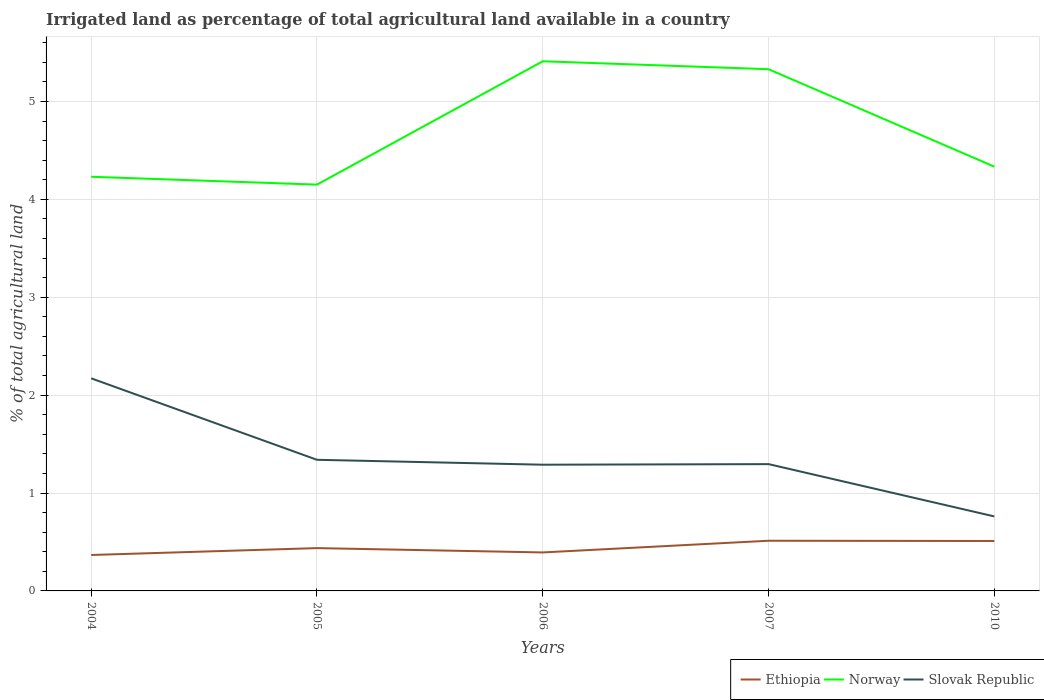Does the line corresponding to Ethiopia intersect with the line corresponding to Norway?
Give a very brief answer. No. Across all years, what is the maximum percentage of irrigated land in Slovak Republic?
Offer a very short reply. 0.76. In which year was the percentage of irrigated land in Norway maximum?
Provide a short and direct response. 2005. What is the total percentage of irrigated land in Norway in the graph?
Ensure brevity in your answer.  -0.1. What is the difference between the highest and the second highest percentage of irrigated land in Slovak Republic?
Keep it short and to the point. 1.41. Is the percentage of irrigated land in Slovak Republic strictly greater than the percentage of irrigated land in Ethiopia over the years?
Give a very brief answer. No. Does the graph contain grids?
Keep it short and to the point. Yes. How are the legend labels stacked?
Your answer should be compact. Horizontal. What is the title of the graph?
Your answer should be compact. Irrigated land as percentage of total agricultural land available in a country. What is the label or title of the X-axis?
Provide a succinct answer. Years. What is the label or title of the Y-axis?
Ensure brevity in your answer.  % of total agricultural land. What is the % of total agricultural land in Ethiopia in 2004?
Give a very brief answer. 0.37. What is the % of total agricultural land of Norway in 2004?
Make the answer very short. 4.23. What is the % of total agricultural land in Slovak Republic in 2004?
Provide a succinct answer. 2.17. What is the % of total agricultural land of Ethiopia in 2005?
Provide a succinct answer. 0.44. What is the % of total agricultural land in Norway in 2005?
Your answer should be very brief. 4.15. What is the % of total agricultural land in Slovak Republic in 2005?
Your answer should be very brief. 1.34. What is the % of total agricultural land in Ethiopia in 2006?
Your response must be concise. 0.39. What is the % of total agricultural land in Norway in 2006?
Your response must be concise. 5.41. What is the % of total agricultural land of Slovak Republic in 2006?
Your answer should be compact. 1.29. What is the % of total agricultural land in Ethiopia in 2007?
Your answer should be compact. 0.51. What is the % of total agricultural land of Norway in 2007?
Your response must be concise. 5.33. What is the % of total agricultural land of Slovak Republic in 2007?
Your response must be concise. 1.3. What is the % of total agricultural land of Ethiopia in 2010?
Provide a succinct answer. 0.51. What is the % of total agricultural land of Norway in 2010?
Give a very brief answer. 4.33. What is the % of total agricultural land in Slovak Republic in 2010?
Your answer should be compact. 0.76. Across all years, what is the maximum % of total agricultural land of Ethiopia?
Your response must be concise. 0.51. Across all years, what is the maximum % of total agricultural land of Norway?
Make the answer very short. 5.41. Across all years, what is the maximum % of total agricultural land of Slovak Republic?
Provide a short and direct response. 2.17. Across all years, what is the minimum % of total agricultural land of Ethiopia?
Your answer should be very brief. 0.37. Across all years, what is the minimum % of total agricultural land in Norway?
Provide a short and direct response. 4.15. Across all years, what is the minimum % of total agricultural land in Slovak Republic?
Your response must be concise. 0.76. What is the total % of total agricultural land of Ethiopia in the graph?
Offer a terse response. 2.22. What is the total % of total agricultural land in Norway in the graph?
Provide a short and direct response. 23.46. What is the total % of total agricultural land in Slovak Republic in the graph?
Provide a short and direct response. 6.86. What is the difference between the % of total agricultural land in Ethiopia in 2004 and that in 2005?
Provide a succinct answer. -0.07. What is the difference between the % of total agricultural land in Norway in 2004 and that in 2005?
Provide a succinct answer. 0.08. What is the difference between the % of total agricultural land in Slovak Republic in 2004 and that in 2005?
Offer a very short reply. 0.83. What is the difference between the % of total agricultural land of Ethiopia in 2004 and that in 2006?
Your response must be concise. -0.03. What is the difference between the % of total agricultural land of Norway in 2004 and that in 2006?
Provide a short and direct response. -1.18. What is the difference between the % of total agricultural land in Slovak Republic in 2004 and that in 2006?
Give a very brief answer. 0.88. What is the difference between the % of total agricultural land of Ethiopia in 2004 and that in 2007?
Ensure brevity in your answer.  -0.15. What is the difference between the % of total agricultural land of Norway in 2004 and that in 2007?
Your response must be concise. -1.1. What is the difference between the % of total agricultural land in Slovak Republic in 2004 and that in 2007?
Your answer should be very brief. 0.88. What is the difference between the % of total agricultural land in Ethiopia in 2004 and that in 2010?
Offer a very short reply. -0.14. What is the difference between the % of total agricultural land in Norway in 2004 and that in 2010?
Make the answer very short. -0.1. What is the difference between the % of total agricultural land in Slovak Republic in 2004 and that in 2010?
Keep it short and to the point. 1.41. What is the difference between the % of total agricultural land of Ethiopia in 2005 and that in 2006?
Provide a short and direct response. 0.04. What is the difference between the % of total agricultural land in Norway in 2005 and that in 2006?
Offer a very short reply. -1.26. What is the difference between the % of total agricultural land of Slovak Republic in 2005 and that in 2006?
Your response must be concise. 0.05. What is the difference between the % of total agricultural land in Ethiopia in 2005 and that in 2007?
Your response must be concise. -0.08. What is the difference between the % of total agricultural land in Norway in 2005 and that in 2007?
Keep it short and to the point. -1.18. What is the difference between the % of total agricultural land of Slovak Republic in 2005 and that in 2007?
Your response must be concise. 0.04. What is the difference between the % of total agricultural land of Ethiopia in 2005 and that in 2010?
Offer a terse response. -0.07. What is the difference between the % of total agricultural land of Norway in 2005 and that in 2010?
Provide a succinct answer. -0.18. What is the difference between the % of total agricultural land in Slovak Republic in 2005 and that in 2010?
Your answer should be very brief. 0.58. What is the difference between the % of total agricultural land of Ethiopia in 2006 and that in 2007?
Provide a succinct answer. -0.12. What is the difference between the % of total agricultural land in Norway in 2006 and that in 2007?
Provide a short and direct response. 0.08. What is the difference between the % of total agricultural land in Slovak Republic in 2006 and that in 2007?
Make the answer very short. -0.01. What is the difference between the % of total agricultural land in Ethiopia in 2006 and that in 2010?
Your response must be concise. -0.12. What is the difference between the % of total agricultural land in Norway in 2006 and that in 2010?
Your answer should be compact. 1.08. What is the difference between the % of total agricultural land in Slovak Republic in 2006 and that in 2010?
Provide a succinct answer. 0.53. What is the difference between the % of total agricultural land in Ethiopia in 2007 and that in 2010?
Ensure brevity in your answer.  0. What is the difference between the % of total agricultural land of Norway in 2007 and that in 2010?
Your answer should be very brief. 1. What is the difference between the % of total agricultural land in Slovak Republic in 2007 and that in 2010?
Give a very brief answer. 0.53. What is the difference between the % of total agricultural land of Ethiopia in 2004 and the % of total agricultural land of Norway in 2005?
Your response must be concise. -3.78. What is the difference between the % of total agricultural land of Ethiopia in 2004 and the % of total agricultural land of Slovak Republic in 2005?
Provide a short and direct response. -0.97. What is the difference between the % of total agricultural land of Norway in 2004 and the % of total agricultural land of Slovak Republic in 2005?
Your answer should be very brief. 2.89. What is the difference between the % of total agricultural land in Ethiopia in 2004 and the % of total agricultural land in Norway in 2006?
Provide a short and direct response. -5.04. What is the difference between the % of total agricultural land of Ethiopia in 2004 and the % of total agricultural land of Slovak Republic in 2006?
Offer a terse response. -0.92. What is the difference between the % of total agricultural land of Norway in 2004 and the % of total agricultural land of Slovak Republic in 2006?
Keep it short and to the point. 2.94. What is the difference between the % of total agricultural land in Ethiopia in 2004 and the % of total agricultural land in Norway in 2007?
Provide a short and direct response. -4.96. What is the difference between the % of total agricultural land in Ethiopia in 2004 and the % of total agricultural land in Slovak Republic in 2007?
Your answer should be very brief. -0.93. What is the difference between the % of total agricultural land in Norway in 2004 and the % of total agricultural land in Slovak Republic in 2007?
Make the answer very short. 2.94. What is the difference between the % of total agricultural land of Ethiopia in 2004 and the % of total agricultural land of Norway in 2010?
Offer a terse response. -3.97. What is the difference between the % of total agricultural land in Ethiopia in 2004 and the % of total agricultural land in Slovak Republic in 2010?
Ensure brevity in your answer.  -0.39. What is the difference between the % of total agricultural land of Norway in 2004 and the % of total agricultural land of Slovak Republic in 2010?
Offer a very short reply. 3.47. What is the difference between the % of total agricultural land in Ethiopia in 2005 and the % of total agricultural land in Norway in 2006?
Ensure brevity in your answer.  -4.97. What is the difference between the % of total agricultural land of Ethiopia in 2005 and the % of total agricultural land of Slovak Republic in 2006?
Your answer should be very brief. -0.85. What is the difference between the % of total agricultural land of Norway in 2005 and the % of total agricultural land of Slovak Republic in 2006?
Offer a terse response. 2.86. What is the difference between the % of total agricultural land of Ethiopia in 2005 and the % of total agricultural land of Norway in 2007?
Make the answer very short. -4.89. What is the difference between the % of total agricultural land of Ethiopia in 2005 and the % of total agricultural land of Slovak Republic in 2007?
Provide a succinct answer. -0.86. What is the difference between the % of total agricultural land of Norway in 2005 and the % of total agricultural land of Slovak Republic in 2007?
Give a very brief answer. 2.86. What is the difference between the % of total agricultural land in Ethiopia in 2005 and the % of total agricultural land in Norway in 2010?
Give a very brief answer. -3.9. What is the difference between the % of total agricultural land of Ethiopia in 2005 and the % of total agricultural land of Slovak Republic in 2010?
Make the answer very short. -0.32. What is the difference between the % of total agricultural land in Norway in 2005 and the % of total agricultural land in Slovak Republic in 2010?
Offer a very short reply. 3.39. What is the difference between the % of total agricultural land of Ethiopia in 2006 and the % of total agricultural land of Norway in 2007?
Provide a short and direct response. -4.94. What is the difference between the % of total agricultural land in Ethiopia in 2006 and the % of total agricultural land in Slovak Republic in 2007?
Your answer should be very brief. -0.9. What is the difference between the % of total agricultural land of Norway in 2006 and the % of total agricultural land of Slovak Republic in 2007?
Give a very brief answer. 4.12. What is the difference between the % of total agricultural land in Ethiopia in 2006 and the % of total agricultural land in Norway in 2010?
Make the answer very short. -3.94. What is the difference between the % of total agricultural land of Ethiopia in 2006 and the % of total agricultural land of Slovak Republic in 2010?
Give a very brief answer. -0.37. What is the difference between the % of total agricultural land in Norway in 2006 and the % of total agricultural land in Slovak Republic in 2010?
Make the answer very short. 4.65. What is the difference between the % of total agricultural land of Ethiopia in 2007 and the % of total agricultural land of Norway in 2010?
Ensure brevity in your answer.  -3.82. What is the difference between the % of total agricultural land in Ethiopia in 2007 and the % of total agricultural land in Slovak Republic in 2010?
Provide a short and direct response. -0.25. What is the difference between the % of total agricultural land in Norway in 2007 and the % of total agricultural land in Slovak Republic in 2010?
Your response must be concise. 4.57. What is the average % of total agricultural land of Ethiopia per year?
Keep it short and to the point. 0.44. What is the average % of total agricultural land in Norway per year?
Keep it short and to the point. 4.69. What is the average % of total agricultural land of Slovak Republic per year?
Your answer should be very brief. 1.37. In the year 2004, what is the difference between the % of total agricultural land in Ethiopia and % of total agricultural land in Norway?
Give a very brief answer. -3.86. In the year 2004, what is the difference between the % of total agricultural land of Ethiopia and % of total agricultural land of Slovak Republic?
Your response must be concise. -1.8. In the year 2004, what is the difference between the % of total agricultural land in Norway and % of total agricultural land in Slovak Republic?
Give a very brief answer. 2.06. In the year 2005, what is the difference between the % of total agricultural land in Ethiopia and % of total agricultural land in Norway?
Offer a terse response. -3.71. In the year 2005, what is the difference between the % of total agricultural land of Ethiopia and % of total agricultural land of Slovak Republic?
Your response must be concise. -0.9. In the year 2005, what is the difference between the % of total agricultural land in Norway and % of total agricultural land in Slovak Republic?
Your answer should be compact. 2.81. In the year 2006, what is the difference between the % of total agricultural land of Ethiopia and % of total agricultural land of Norway?
Give a very brief answer. -5.02. In the year 2006, what is the difference between the % of total agricultural land of Ethiopia and % of total agricultural land of Slovak Republic?
Make the answer very short. -0.9. In the year 2006, what is the difference between the % of total agricultural land of Norway and % of total agricultural land of Slovak Republic?
Offer a very short reply. 4.12. In the year 2007, what is the difference between the % of total agricultural land in Ethiopia and % of total agricultural land in Norway?
Offer a terse response. -4.82. In the year 2007, what is the difference between the % of total agricultural land of Ethiopia and % of total agricultural land of Slovak Republic?
Give a very brief answer. -0.78. In the year 2007, what is the difference between the % of total agricultural land in Norway and % of total agricultural land in Slovak Republic?
Make the answer very short. 4.03. In the year 2010, what is the difference between the % of total agricultural land of Ethiopia and % of total agricultural land of Norway?
Provide a short and direct response. -3.82. In the year 2010, what is the difference between the % of total agricultural land in Ethiopia and % of total agricultural land in Slovak Republic?
Your answer should be compact. -0.25. In the year 2010, what is the difference between the % of total agricultural land in Norway and % of total agricultural land in Slovak Republic?
Offer a terse response. 3.57. What is the ratio of the % of total agricultural land of Ethiopia in 2004 to that in 2005?
Provide a succinct answer. 0.84. What is the ratio of the % of total agricultural land of Norway in 2004 to that in 2005?
Offer a terse response. 1.02. What is the ratio of the % of total agricultural land of Slovak Republic in 2004 to that in 2005?
Your response must be concise. 1.62. What is the ratio of the % of total agricultural land in Ethiopia in 2004 to that in 2006?
Your answer should be very brief. 0.93. What is the ratio of the % of total agricultural land of Norway in 2004 to that in 2006?
Ensure brevity in your answer.  0.78. What is the ratio of the % of total agricultural land of Slovak Republic in 2004 to that in 2006?
Ensure brevity in your answer.  1.68. What is the ratio of the % of total agricultural land of Ethiopia in 2004 to that in 2007?
Give a very brief answer. 0.72. What is the ratio of the % of total agricultural land of Norway in 2004 to that in 2007?
Offer a very short reply. 0.79. What is the ratio of the % of total agricultural land of Slovak Republic in 2004 to that in 2007?
Offer a terse response. 1.68. What is the ratio of the % of total agricultural land in Ethiopia in 2004 to that in 2010?
Offer a very short reply. 0.72. What is the ratio of the % of total agricultural land in Norway in 2004 to that in 2010?
Offer a very short reply. 0.98. What is the ratio of the % of total agricultural land in Slovak Republic in 2004 to that in 2010?
Your response must be concise. 2.85. What is the ratio of the % of total agricultural land in Ethiopia in 2005 to that in 2006?
Offer a very short reply. 1.11. What is the ratio of the % of total agricultural land of Norway in 2005 to that in 2006?
Ensure brevity in your answer.  0.77. What is the ratio of the % of total agricultural land of Slovak Republic in 2005 to that in 2006?
Give a very brief answer. 1.04. What is the ratio of the % of total agricultural land of Ethiopia in 2005 to that in 2007?
Provide a succinct answer. 0.85. What is the ratio of the % of total agricultural land in Norway in 2005 to that in 2007?
Ensure brevity in your answer.  0.78. What is the ratio of the % of total agricultural land of Slovak Republic in 2005 to that in 2007?
Offer a terse response. 1.03. What is the ratio of the % of total agricultural land in Ethiopia in 2005 to that in 2010?
Provide a succinct answer. 0.86. What is the ratio of the % of total agricultural land in Norway in 2005 to that in 2010?
Provide a succinct answer. 0.96. What is the ratio of the % of total agricultural land of Slovak Republic in 2005 to that in 2010?
Make the answer very short. 1.76. What is the ratio of the % of total agricultural land of Ethiopia in 2006 to that in 2007?
Provide a succinct answer. 0.77. What is the ratio of the % of total agricultural land in Norway in 2006 to that in 2007?
Your answer should be compact. 1.02. What is the ratio of the % of total agricultural land in Ethiopia in 2006 to that in 2010?
Make the answer very short. 0.77. What is the ratio of the % of total agricultural land of Norway in 2006 to that in 2010?
Give a very brief answer. 1.25. What is the ratio of the % of total agricultural land in Slovak Republic in 2006 to that in 2010?
Your answer should be very brief. 1.69. What is the ratio of the % of total agricultural land of Norway in 2007 to that in 2010?
Make the answer very short. 1.23. What is the ratio of the % of total agricultural land of Slovak Republic in 2007 to that in 2010?
Your answer should be compact. 1.7. What is the difference between the highest and the second highest % of total agricultural land in Ethiopia?
Offer a terse response. 0. What is the difference between the highest and the second highest % of total agricultural land in Norway?
Give a very brief answer. 0.08. What is the difference between the highest and the second highest % of total agricultural land in Slovak Republic?
Your answer should be very brief. 0.83. What is the difference between the highest and the lowest % of total agricultural land of Ethiopia?
Provide a short and direct response. 0.15. What is the difference between the highest and the lowest % of total agricultural land of Norway?
Your answer should be very brief. 1.26. What is the difference between the highest and the lowest % of total agricultural land in Slovak Republic?
Keep it short and to the point. 1.41. 